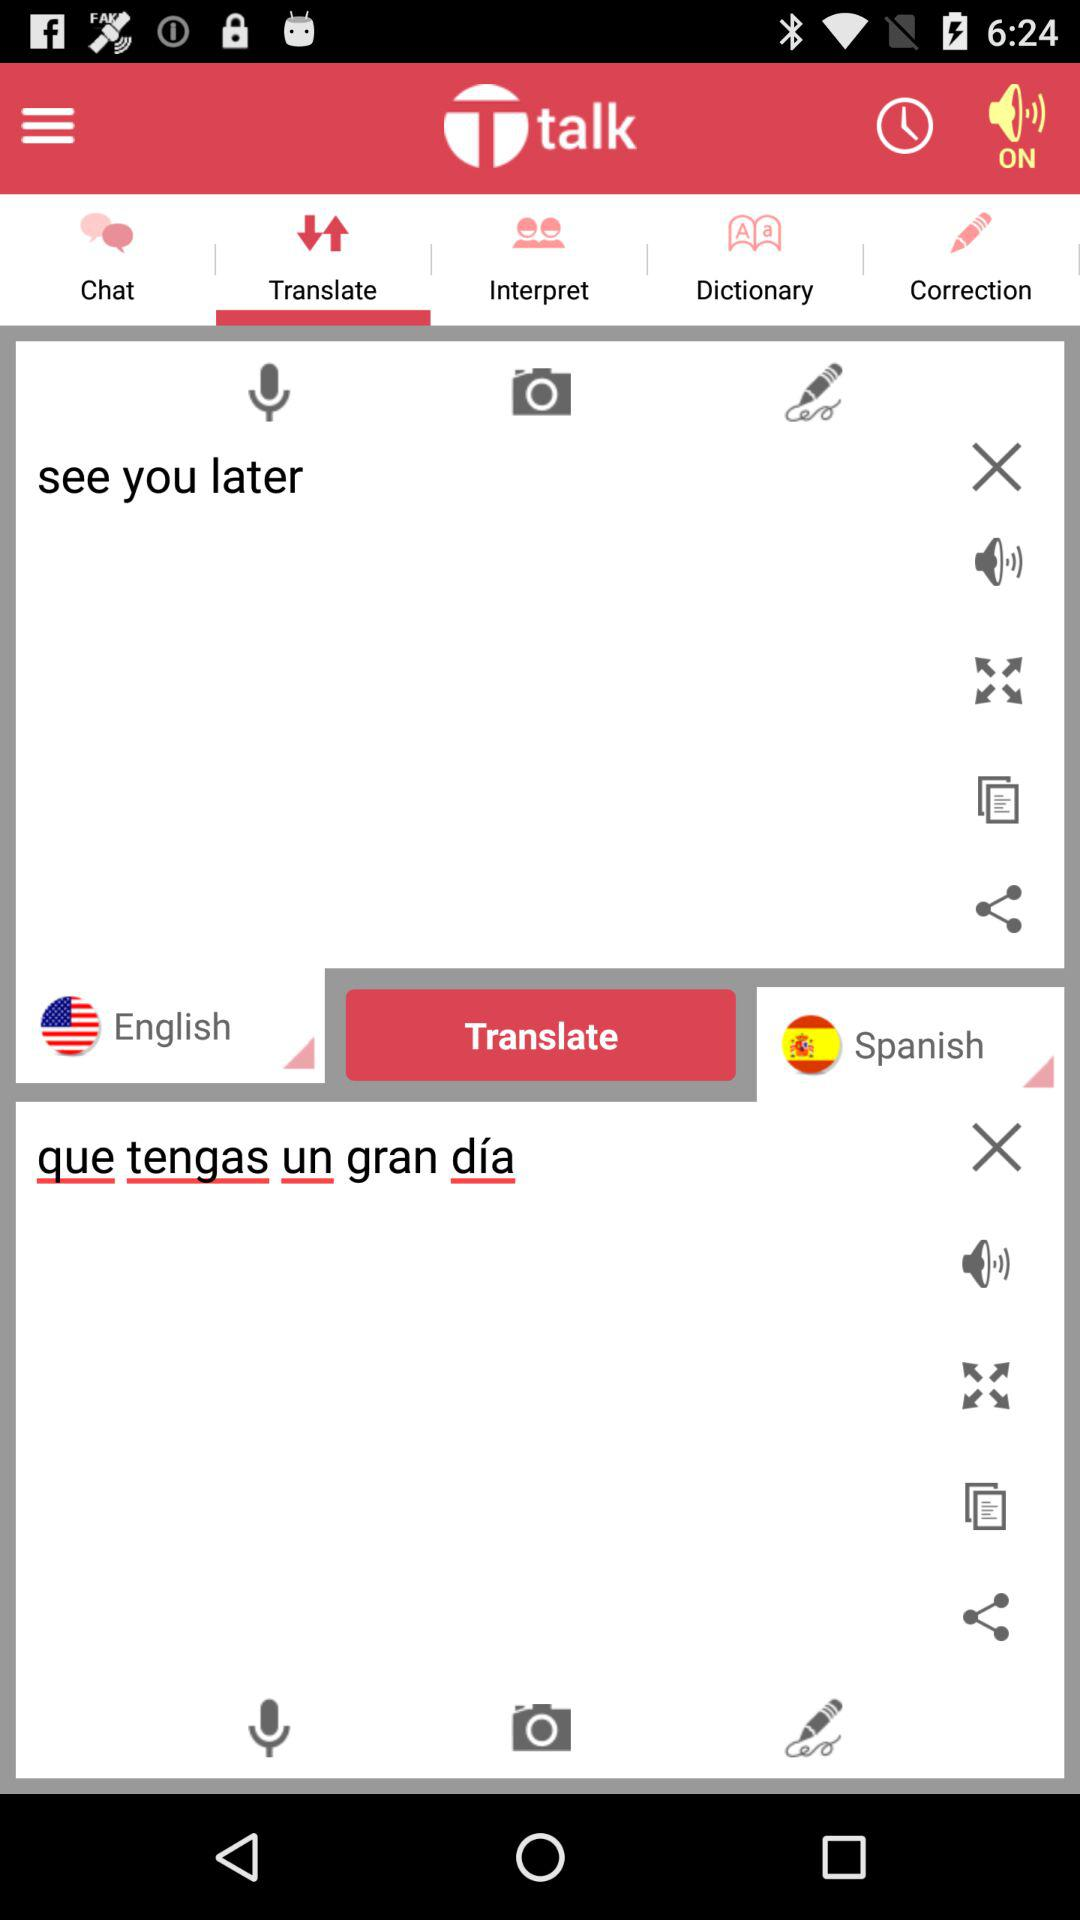In what language does this application translate the English language? The English language is translated into Spanish. 